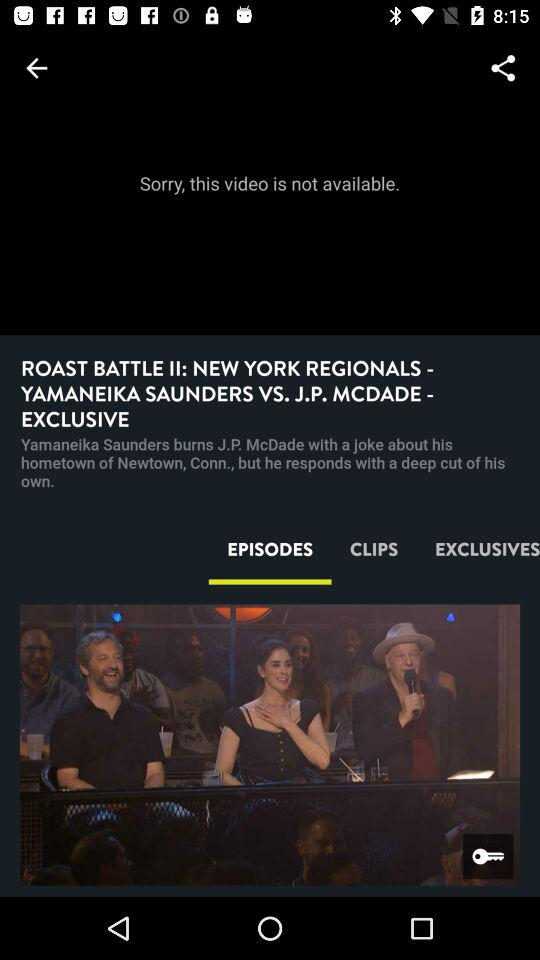Which tab is selected? The selected tab is "EPISODES". 